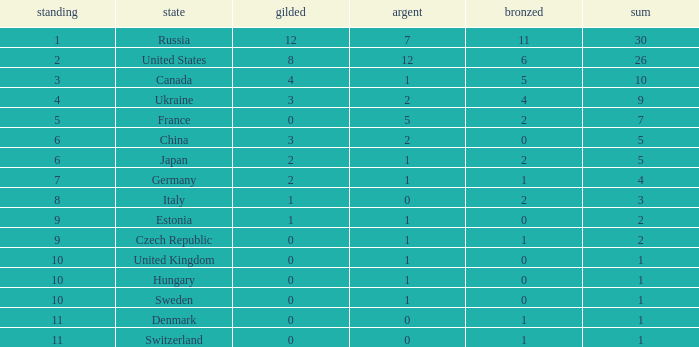What is the largest silver with Gold larger than 4, a Nation of united states, and a Total larger than 26? None. 